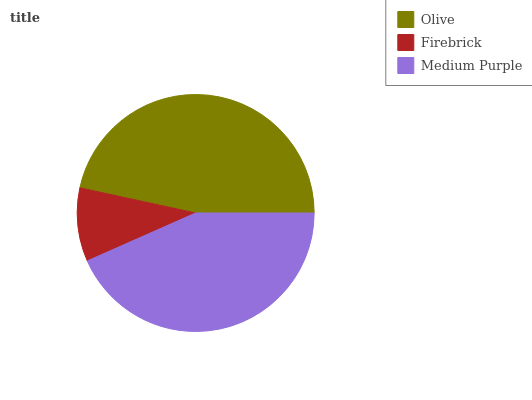Is Firebrick the minimum?
Answer yes or no. Yes. Is Olive the maximum?
Answer yes or no. Yes. Is Medium Purple the minimum?
Answer yes or no. No. Is Medium Purple the maximum?
Answer yes or no. No. Is Medium Purple greater than Firebrick?
Answer yes or no. Yes. Is Firebrick less than Medium Purple?
Answer yes or no. Yes. Is Firebrick greater than Medium Purple?
Answer yes or no. No. Is Medium Purple less than Firebrick?
Answer yes or no. No. Is Medium Purple the high median?
Answer yes or no. Yes. Is Medium Purple the low median?
Answer yes or no. Yes. Is Firebrick the high median?
Answer yes or no. No. Is Olive the low median?
Answer yes or no. No. 